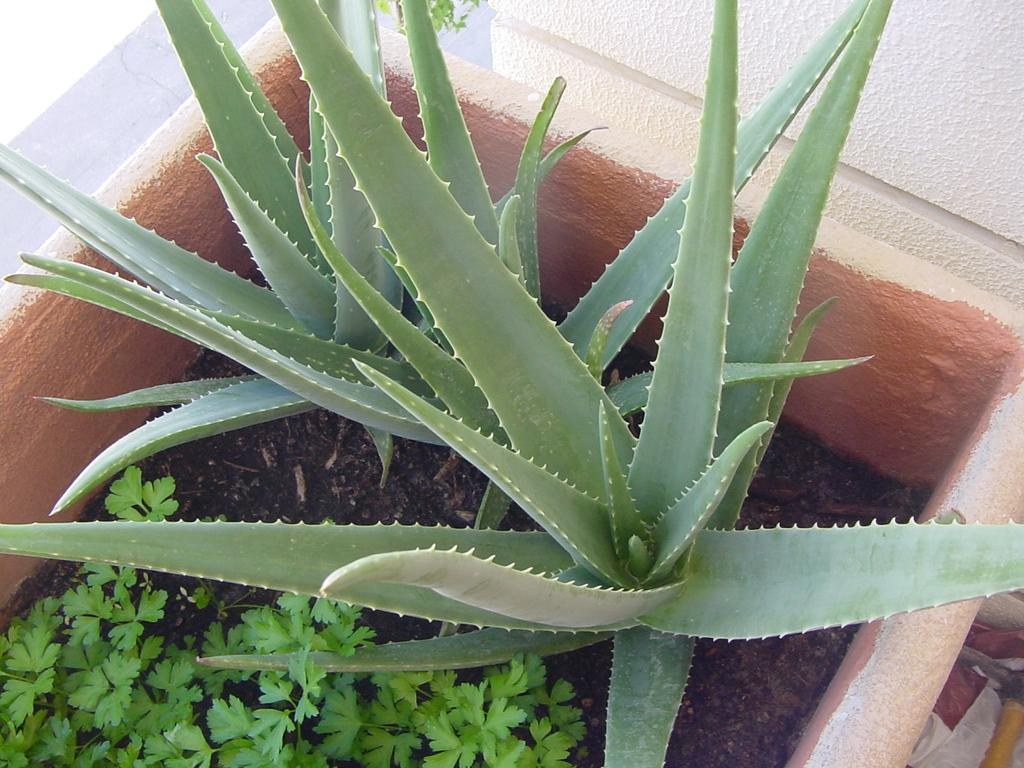What is located in the center of the image? There are potted plants in the center of the image. What color are the leaves of the potted plants? The potted plants have green leaves. What type of surface is visible in the background of the image? There is ground visible in the background of the image. What else can be seen in the background of the image? There are other objects present in the background of the image. What is the value of the ink used to draw the potted plants in the image? There is no ink present in the image, as it is a photograph of real potted plants. 